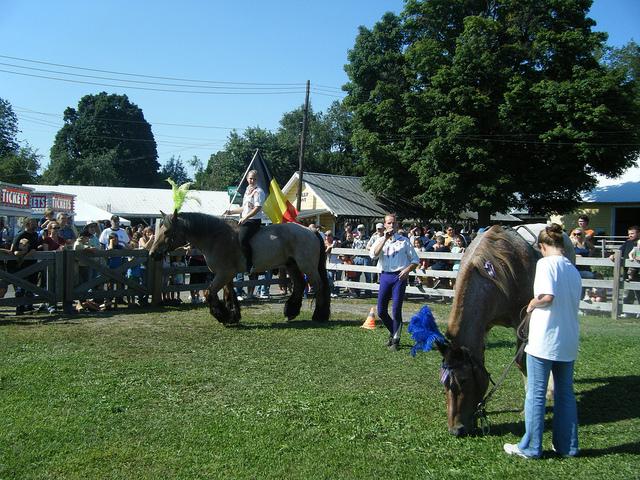Which horse is in motion?
Answer briefly. Yes. Is anyone riding the horse?
Concise answer only. Yes. How many horses are eating grass?
Quick response, please. 1. Are the horses the same color?
Short answer required. Yes. Is this a circus?
Keep it brief. No. 